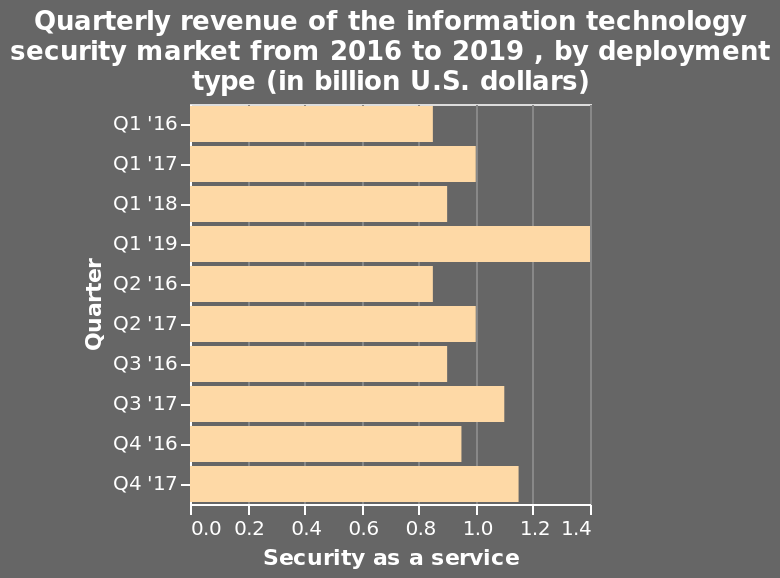<image>
What was the highest quarterly revenue and in which year was it recorded? The highest quarterly revenue was 1.4 billion dollars, and it was recorded in Q1 2019. 